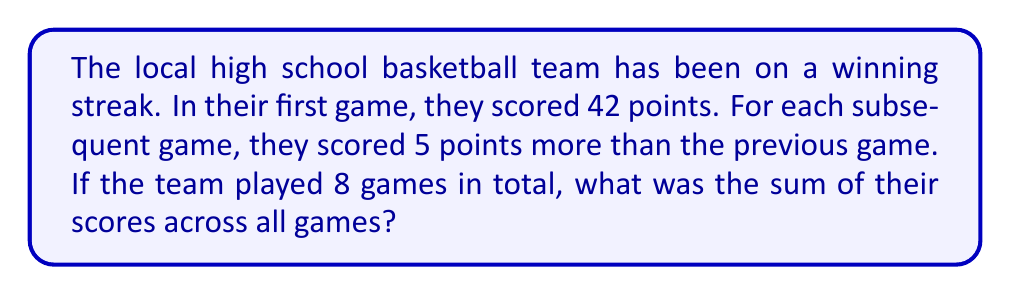Could you help me with this problem? Let's approach this step-by-step:

1) First, we need to recognize that this is an arithmetic sequence. The first term $a_1 = 42$, and the common difference $d = 5$.

2) The sequence of scores will be:
   42, 47, 52, 57, 62, 67, 72, 77

3) To find the sum of this sequence, we can use the formula for the sum of an arithmetic sequence:

   $$S_n = \frac{n}{2}(a_1 + a_n)$$

   Where $S_n$ is the sum of the sequence, $n$ is the number of terms, $a_1$ is the first term, and $a_n$ is the last term.

4) We know $n = 8$ and $a_1 = 42$. We need to find $a_8$.

5) We can find $a_8$ using the arithmetic sequence formula:
   $$a_n = a_1 + (n-1)d$$
   $$a_8 = 42 + (8-1)5 = 42 + 35 = 77$$

6) Now we can plug these values into our sum formula:

   $$S_8 = \frac{8}{2}(42 + 77) = 4(119) = 476$$

Therefore, the total points scored over the 8 games is 476.
Answer: 476 points 